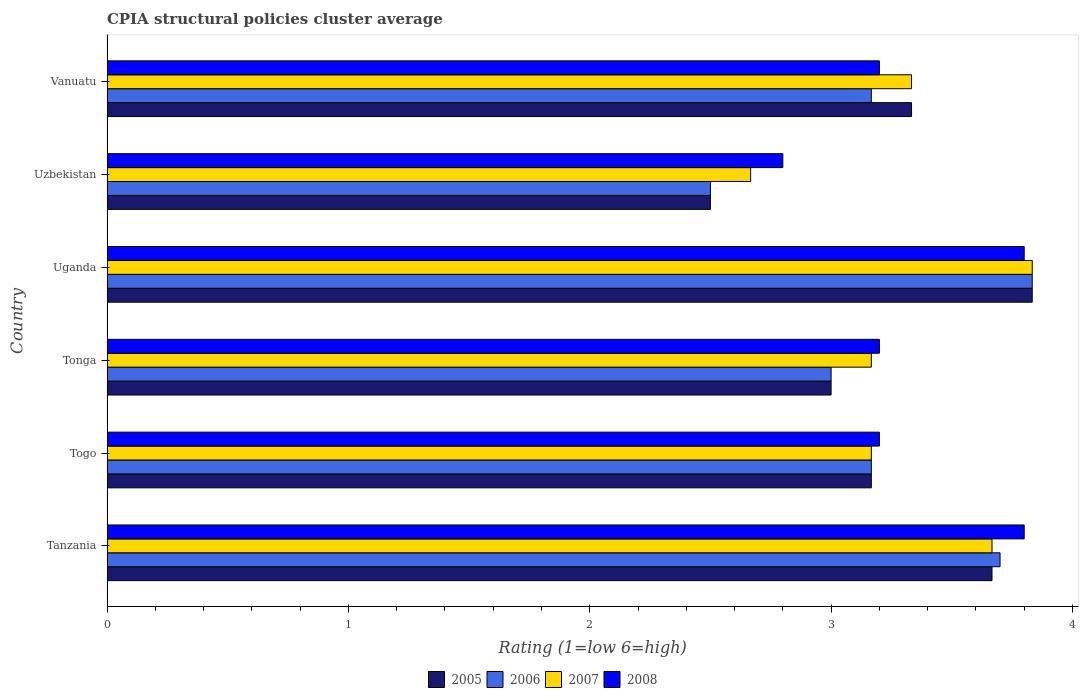How many groups of bars are there?
Give a very brief answer. 6. How many bars are there on the 1st tick from the bottom?
Ensure brevity in your answer.  4. What is the label of the 1st group of bars from the top?
Your answer should be compact. Vanuatu. Across all countries, what is the maximum CPIA rating in 2005?
Offer a very short reply. 3.83. In which country was the CPIA rating in 2005 maximum?
Provide a succinct answer. Uganda. In which country was the CPIA rating in 2007 minimum?
Provide a succinct answer. Uzbekistan. What is the total CPIA rating in 2006 in the graph?
Offer a terse response. 19.37. What is the difference between the CPIA rating in 2007 in Tonga and that in Uzbekistan?
Your answer should be compact. 0.5. What is the difference between the CPIA rating in 2006 in Uzbekistan and the CPIA rating in 2008 in Tonga?
Ensure brevity in your answer.  -0.7. What is the average CPIA rating in 2005 per country?
Provide a succinct answer. 3.25. What is the difference between the CPIA rating in 2006 and CPIA rating in 2005 in Vanuatu?
Provide a succinct answer. -0.17. What is the ratio of the CPIA rating in 2006 in Tanzania to that in Vanuatu?
Provide a short and direct response. 1.17. What is the difference between the highest and the second highest CPIA rating in 2006?
Provide a succinct answer. 0.13. What is the difference between the highest and the lowest CPIA rating in 2008?
Your response must be concise. 1. In how many countries, is the CPIA rating in 2006 greater than the average CPIA rating in 2006 taken over all countries?
Offer a terse response. 2. Is it the case that in every country, the sum of the CPIA rating in 2005 and CPIA rating in 2007 is greater than the sum of CPIA rating in 2008 and CPIA rating in 2006?
Your answer should be compact. No. What does the 3rd bar from the top in Uganda represents?
Your answer should be very brief. 2006. Is it the case that in every country, the sum of the CPIA rating in 2008 and CPIA rating in 2007 is greater than the CPIA rating in 2005?
Keep it short and to the point. Yes. How many countries are there in the graph?
Provide a succinct answer. 6. What is the difference between two consecutive major ticks on the X-axis?
Offer a terse response. 1. Are the values on the major ticks of X-axis written in scientific E-notation?
Your answer should be very brief. No. Does the graph contain grids?
Your answer should be compact. No. Where does the legend appear in the graph?
Keep it short and to the point. Bottom center. What is the title of the graph?
Ensure brevity in your answer.  CPIA structural policies cluster average. What is the label or title of the X-axis?
Ensure brevity in your answer.  Rating (1=low 6=high). What is the label or title of the Y-axis?
Your response must be concise. Country. What is the Rating (1=low 6=high) of 2005 in Tanzania?
Give a very brief answer. 3.67. What is the Rating (1=low 6=high) of 2007 in Tanzania?
Your response must be concise. 3.67. What is the Rating (1=low 6=high) in 2005 in Togo?
Keep it short and to the point. 3.17. What is the Rating (1=low 6=high) in 2006 in Togo?
Make the answer very short. 3.17. What is the Rating (1=low 6=high) of 2007 in Togo?
Keep it short and to the point. 3.17. What is the Rating (1=low 6=high) in 2008 in Togo?
Offer a terse response. 3.2. What is the Rating (1=low 6=high) in 2006 in Tonga?
Provide a succinct answer. 3. What is the Rating (1=low 6=high) in 2007 in Tonga?
Provide a succinct answer. 3.17. What is the Rating (1=low 6=high) of 2005 in Uganda?
Offer a very short reply. 3.83. What is the Rating (1=low 6=high) in 2006 in Uganda?
Provide a succinct answer. 3.83. What is the Rating (1=low 6=high) of 2007 in Uganda?
Provide a short and direct response. 3.83. What is the Rating (1=low 6=high) of 2008 in Uganda?
Give a very brief answer. 3.8. What is the Rating (1=low 6=high) in 2007 in Uzbekistan?
Make the answer very short. 2.67. What is the Rating (1=low 6=high) of 2005 in Vanuatu?
Provide a succinct answer. 3.33. What is the Rating (1=low 6=high) in 2006 in Vanuatu?
Your response must be concise. 3.17. What is the Rating (1=low 6=high) in 2007 in Vanuatu?
Ensure brevity in your answer.  3.33. What is the Rating (1=low 6=high) in 2008 in Vanuatu?
Provide a short and direct response. 3.2. Across all countries, what is the maximum Rating (1=low 6=high) in 2005?
Make the answer very short. 3.83. Across all countries, what is the maximum Rating (1=low 6=high) of 2006?
Make the answer very short. 3.83. Across all countries, what is the maximum Rating (1=low 6=high) in 2007?
Ensure brevity in your answer.  3.83. Across all countries, what is the minimum Rating (1=low 6=high) in 2007?
Offer a very short reply. 2.67. What is the total Rating (1=low 6=high) of 2006 in the graph?
Offer a terse response. 19.37. What is the total Rating (1=low 6=high) in 2007 in the graph?
Ensure brevity in your answer.  19.83. What is the total Rating (1=low 6=high) of 2008 in the graph?
Your answer should be very brief. 20. What is the difference between the Rating (1=low 6=high) of 2006 in Tanzania and that in Togo?
Offer a very short reply. 0.53. What is the difference between the Rating (1=low 6=high) in 2007 in Tanzania and that in Tonga?
Your answer should be compact. 0.5. What is the difference between the Rating (1=low 6=high) in 2008 in Tanzania and that in Tonga?
Provide a succinct answer. 0.6. What is the difference between the Rating (1=low 6=high) in 2006 in Tanzania and that in Uganda?
Give a very brief answer. -0.13. What is the difference between the Rating (1=low 6=high) of 2008 in Tanzania and that in Uganda?
Your response must be concise. 0. What is the difference between the Rating (1=low 6=high) of 2005 in Tanzania and that in Uzbekistan?
Offer a terse response. 1.17. What is the difference between the Rating (1=low 6=high) in 2006 in Tanzania and that in Uzbekistan?
Keep it short and to the point. 1.2. What is the difference between the Rating (1=low 6=high) of 2007 in Tanzania and that in Uzbekistan?
Give a very brief answer. 1. What is the difference between the Rating (1=low 6=high) of 2008 in Tanzania and that in Uzbekistan?
Provide a succinct answer. 1. What is the difference between the Rating (1=low 6=high) in 2006 in Tanzania and that in Vanuatu?
Offer a very short reply. 0.53. What is the difference between the Rating (1=low 6=high) of 2005 in Togo and that in Tonga?
Ensure brevity in your answer.  0.17. What is the difference between the Rating (1=low 6=high) of 2006 in Togo and that in Tonga?
Make the answer very short. 0.17. What is the difference between the Rating (1=low 6=high) in 2008 in Togo and that in Tonga?
Your answer should be compact. 0. What is the difference between the Rating (1=low 6=high) of 2006 in Togo and that in Uganda?
Provide a succinct answer. -0.67. What is the difference between the Rating (1=low 6=high) in 2007 in Togo and that in Uganda?
Your answer should be very brief. -0.67. What is the difference between the Rating (1=low 6=high) in 2005 in Togo and that in Uzbekistan?
Your response must be concise. 0.67. What is the difference between the Rating (1=low 6=high) of 2006 in Togo and that in Uzbekistan?
Provide a succinct answer. 0.67. What is the difference between the Rating (1=low 6=high) of 2007 in Togo and that in Vanuatu?
Ensure brevity in your answer.  -0.17. What is the difference between the Rating (1=low 6=high) of 2006 in Tonga and that in Uganda?
Offer a very short reply. -0.83. What is the difference between the Rating (1=low 6=high) in 2007 in Tonga and that in Uganda?
Provide a short and direct response. -0.67. What is the difference between the Rating (1=low 6=high) of 2005 in Tonga and that in Uzbekistan?
Give a very brief answer. 0.5. What is the difference between the Rating (1=low 6=high) in 2007 in Tonga and that in Uzbekistan?
Your response must be concise. 0.5. What is the difference between the Rating (1=low 6=high) in 2006 in Tonga and that in Vanuatu?
Provide a short and direct response. -0.17. What is the difference between the Rating (1=low 6=high) in 2007 in Tonga and that in Vanuatu?
Keep it short and to the point. -0.17. What is the difference between the Rating (1=low 6=high) in 2008 in Tonga and that in Vanuatu?
Make the answer very short. 0. What is the difference between the Rating (1=low 6=high) of 2005 in Uganda and that in Uzbekistan?
Ensure brevity in your answer.  1.33. What is the difference between the Rating (1=low 6=high) of 2007 in Uganda and that in Uzbekistan?
Offer a very short reply. 1.17. What is the difference between the Rating (1=low 6=high) of 2008 in Uganda and that in Uzbekistan?
Give a very brief answer. 1. What is the difference between the Rating (1=low 6=high) in 2005 in Uganda and that in Vanuatu?
Ensure brevity in your answer.  0.5. What is the difference between the Rating (1=low 6=high) in 2006 in Uganda and that in Vanuatu?
Your answer should be compact. 0.67. What is the difference between the Rating (1=low 6=high) of 2007 in Uganda and that in Vanuatu?
Your response must be concise. 0.5. What is the difference between the Rating (1=low 6=high) in 2008 in Uganda and that in Vanuatu?
Your response must be concise. 0.6. What is the difference between the Rating (1=low 6=high) of 2005 in Uzbekistan and that in Vanuatu?
Ensure brevity in your answer.  -0.83. What is the difference between the Rating (1=low 6=high) of 2007 in Uzbekistan and that in Vanuatu?
Give a very brief answer. -0.67. What is the difference between the Rating (1=low 6=high) in 2005 in Tanzania and the Rating (1=low 6=high) in 2008 in Togo?
Your answer should be compact. 0.47. What is the difference between the Rating (1=low 6=high) of 2006 in Tanzania and the Rating (1=low 6=high) of 2007 in Togo?
Offer a very short reply. 0.53. What is the difference between the Rating (1=low 6=high) in 2007 in Tanzania and the Rating (1=low 6=high) in 2008 in Togo?
Offer a terse response. 0.47. What is the difference between the Rating (1=low 6=high) in 2005 in Tanzania and the Rating (1=low 6=high) in 2006 in Tonga?
Make the answer very short. 0.67. What is the difference between the Rating (1=low 6=high) in 2005 in Tanzania and the Rating (1=low 6=high) in 2008 in Tonga?
Offer a terse response. 0.47. What is the difference between the Rating (1=low 6=high) in 2006 in Tanzania and the Rating (1=low 6=high) in 2007 in Tonga?
Provide a succinct answer. 0.53. What is the difference between the Rating (1=low 6=high) in 2007 in Tanzania and the Rating (1=low 6=high) in 2008 in Tonga?
Your answer should be very brief. 0.47. What is the difference between the Rating (1=low 6=high) in 2005 in Tanzania and the Rating (1=low 6=high) in 2006 in Uganda?
Give a very brief answer. -0.17. What is the difference between the Rating (1=low 6=high) of 2005 in Tanzania and the Rating (1=low 6=high) of 2007 in Uganda?
Provide a succinct answer. -0.17. What is the difference between the Rating (1=low 6=high) in 2005 in Tanzania and the Rating (1=low 6=high) in 2008 in Uganda?
Ensure brevity in your answer.  -0.13. What is the difference between the Rating (1=low 6=high) in 2006 in Tanzania and the Rating (1=low 6=high) in 2007 in Uganda?
Provide a succinct answer. -0.13. What is the difference between the Rating (1=low 6=high) of 2006 in Tanzania and the Rating (1=low 6=high) of 2008 in Uganda?
Offer a terse response. -0.1. What is the difference between the Rating (1=low 6=high) of 2007 in Tanzania and the Rating (1=low 6=high) of 2008 in Uganda?
Offer a very short reply. -0.13. What is the difference between the Rating (1=low 6=high) in 2005 in Tanzania and the Rating (1=low 6=high) in 2006 in Uzbekistan?
Keep it short and to the point. 1.17. What is the difference between the Rating (1=low 6=high) of 2005 in Tanzania and the Rating (1=low 6=high) of 2007 in Uzbekistan?
Offer a very short reply. 1. What is the difference between the Rating (1=low 6=high) of 2005 in Tanzania and the Rating (1=low 6=high) of 2008 in Uzbekistan?
Keep it short and to the point. 0.87. What is the difference between the Rating (1=low 6=high) in 2006 in Tanzania and the Rating (1=low 6=high) in 2008 in Uzbekistan?
Offer a terse response. 0.9. What is the difference between the Rating (1=low 6=high) in 2007 in Tanzania and the Rating (1=low 6=high) in 2008 in Uzbekistan?
Ensure brevity in your answer.  0.87. What is the difference between the Rating (1=low 6=high) of 2005 in Tanzania and the Rating (1=low 6=high) of 2006 in Vanuatu?
Provide a short and direct response. 0.5. What is the difference between the Rating (1=low 6=high) of 2005 in Tanzania and the Rating (1=low 6=high) of 2008 in Vanuatu?
Keep it short and to the point. 0.47. What is the difference between the Rating (1=low 6=high) in 2006 in Tanzania and the Rating (1=low 6=high) in 2007 in Vanuatu?
Keep it short and to the point. 0.37. What is the difference between the Rating (1=low 6=high) of 2006 in Tanzania and the Rating (1=low 6=high) of 2008 in Vanuatu?
Give a very brief answer. 0.5. What is the difference between the Rating (1=low 6=high) in 2007 in Tanzania and the Rating (1=low 6=high) in 2008 in Vanuatu?
Keep it short and to the point. 0.47. What is the difference between the Rating (1=low 6=high) in 2005 in Togo and the Rating (1=low 6=high) in 2006 in Tonga?
Provide a short and direct response. 0.17. What is the difference between the Rating (1=low 6=high) in 2005 in Togo and the Rating (1=low 6=high) in 2007 in Tonga?
Give a very brief answer. 0. What is the difference between the Rating (1=low 6=high) in 2005 in Togo and the Rating (1=low 6=high) in 2008 in Tonga?
Ensure brevity in your answer.  -0.03. What is the difference between the Rating (1=low 6=high) in 2006 in Togo and the Rating (1=low 6=high) in 2007 in Tonga?
Provide a short and direct response. 0. What is the difference between the Rating (1=low 6=high) of 2006 in Togo and the Rating (1=low 6=high) of 2008 in Tonga?
Offer a terse response. -0.03. What is the difference between the Rating (1=low 6=high) in 2007 in Togo and the Rating (1=low 6=high) in 2008 in Tonga?
Your answer should be compact. -0.03. What is the difference between the Rating (1=low 6=high) in 2005 in Togo and the Rating (1=low 6=high) in 2007 in Uganda?
Give a very brief answer. -0.67. What is the difference between the Rating (1=low 6=high) of 2005 in Togo and the Rating (1=low 6=high) of 2008 in Uganda?
Your answer should be compact. -0.63. What is the difference between the Rating (1=low 6=high) in 2006 in Togo and the Rating (1=low 6=high) in 2008 in Uganda?
Make the answer very short. -0.63. What is the difference between the Rating (1=low 6=high) in 2007 in Togo and the Rating (1=low 6=high) in 2008 in Uganda?
Your answer should be compact. -0.63. What is the difference between the Rating (1=low 6=high) of 2005 in Togo and the Rating (1=low 6=high) of 2006 in Uzbekistan?
Give a very brief answer. 0.67. What is the difference between the Rating (1=low 6=high) in 2005 in Togo and the Rating (1=low 6=high) in 2008 in Uzbekistan?
Your answer should be very brief. 0.37. What is the difference between the Rating (1=low 6=high) of 2006 in Togo and the Rating (1=low 6=high) of 2008 in Uzbekistan?
Your response must be concise. 0.37. What is the difference between the Rating (1=low 6=high) of 2007 in Togo and the Rating (1=low 6=high) of 2008 in Uzbekistan?
Offer a terse response. 0.37. What is the difference between the Rating (1=low 6=high) in 2005 in Togo and the Rating (1=low 6=high) in 2006 in Vanuatu?
Keep it short and to the point. 0. What is the difference between the Rating (1=low 6=high) of 2005 in Togo and the Rating (1=low 6=high) of 2007 in Vanuatu?
Provide a short and direct response. -0.17. What is the difference between the Rating (1=low 6=high) of 2005 in Togo and the Rating (1=low 6=high) of 2008 in Vanuatu?
Provide a succinct answer. -0.03. What is the difference between the Rating (1=low 6=high) of 2006 in Togo and the Rating (1=low 6=high) of 2007 in Vanuatu?
Provide a short and direct response. -0.17. What is the difference between the Rating (1=low 6=high) in 2006 in Togo and the Rating (1=low 6=high) in 2008 in Vanuatu?
Provide a short and direct response. -0.03. What is the difference between the Rating (1=low 6=high) of 2007 in Togo and the Rating (1=low 6=high) of 2008 in Vanuatu?
Make the answer very short. -0.03. What is the difference between the Rating (1=low 6=high) of 2005 in Tonga and the Rating (1=low 6=high) of 2006 in Uganda?
Your answer should be compact. -0.83. What is the difference between the Rating (1=low 6=high) in 2005 in Tonga and the Rating (1=low 6=high) in 2007 in Uganda?
Provide a succinct answer. -0.83. What is the difference between the Rating (1=low 6=high) of 2005 in Tonga and the Rating (1=low 6=high) of 2008 in Uganda?
Your answer should be very brief. -0.8. What is the difference between the Rating (1=low 6=high) of 2006 in Tonga and the Rating (1=low 6=high) of 2007 in Uganda?
Make the answer very short. -0.83. What is the difference between the Rating (1=low 6=high) in 2006 in Tonga and the Rating (1=low 6=high) in 2008 in Uganda?
Ensure brevity in your answer.  -0.8. What is the difference between the Rating (1=low 6=high) of 2007 in Tonga and the Rating (1=low 6=high) of 2008 in Uganda?
Keep it short and to the point. -0.63. What is the difference between the Rating (1=low 6=high) in 2006 in Tonga and the Rating (1=low 6=high) in 2008 in Uzbekistan?
Keep it short and to the point. 0.2. What is the difference between the Rating (1=low 6=high) in 2007 in Tonga and the Rating (1=low 6=high) in 2008 in Uzbekistan?
Provide a succinct answer. 0.37. What is the difference between the Rating (1=low 6=high) of 2005 in Tonga and the Rating (1=low 6=high) of 2008 in Vanuatu?
Make the answer very short. -0.2. What is the difference between the Rating (1=low 6=high) in 2006 in Tonga and the Rating (1=low 6=high) in 2007 in Vanuatu?
Give a very brief answer. -0.33. What is the difference between the Rating (1=low 6=high) of 2007 in Tonga and the Rating (1=low 6=high) of 2008 in Vanuatu?
Your answer should be very brief. -0.03. What is the difference between the Rating (1=low 6=high) of 2007 in Uganda and the Rating (1=low 6=high) of 2008 in Uzbekistan?
Give a very brief answer. 1.03. What is the difference between the Rating (1=low 6=high) of 2005 in Uganda and the Rating (1=low 6=high) of 2006 in Vanuatu?
Provide a succinct answer. 0.67. What is the difference between the Rating (1=low 6=high) in 2005 in Uganda and the Rating (1=low 6=high) in 2007 in Vanuatu?
Offer a terse response. 0.5. What is the difference between the Rating (1=low 6=high) of 2005 in Uganda and the Rating (1=low 6=high) of 2008 in Vanuatu?
Your response must be concise. 0.63. What is the difference between the Rating (1=low 6=high) of 2006 in Uganda and the Rating (1=low 6=high) of 2008 in Vanuatu?
Your response must be concise. 0.63. What is the difference between the Rating (1=low 6=high) in 2007 in Uganda and the Rating (1=low 6=high) in 2008 in Vanuatu?
Your response must be concise. 0.63. What is the difference between the Rating (1=low 6=high) in 2005 in Uzbekistan and the Rating (1=low 6=high) in 2006 in Vanuatu?
Your answer should be compact. -0.67. What is the difference between the Rating (1=low 6=high) in 2005 in Uzbekistan and the Rating (1=low 6=high) in 2007 in Vanuatu?
Give a very brief answer. -0.83. What is the difference between the Rating (1=low 6=high) in 2005 in Uzbekistan and the Rating (1=low 6=high) in 2008 in Vanuatu?
Your response must be concise. -0.7. What is the difference between the Rating (1=low 6=high) in 2006 in Uzbekistan and the Rating (1=low 6=high) in 2007 in Vanuatu?
Make the answer very short. -0.83. What is the difference between the Rating (1=low 6=high) of 2007 in Uzbekistan and the Rating (1=low 6=high) of 2008 in Vanuatu?
Offer a very short reply. -0.53. What is the average Rating (1=low 6=high) in 2005 per country?
Keep it short and to the point. 3.25. What is the average Rating (1=low 6=high) of 2006 per country?
Offer a terse response. 3.23. What is the average Rating (1=low 6=high) of 2007 per country?
Your answer should be compact. 3.31. What is the average Rating (1=low 6=high) of 2008 per country?
Ensure brevity in your answer.  3.33. What is the difference between the Rating (1=low 6=high) in 2005 and Rating (1=low 6=high) in 2006 in Tanzania?
Provide a succinct answer. -0.03. What is the difference between the Rating (1=low 6=high) in 2005 and Rating (1=low 6=high) in 2008 in Tanzania?
Provide a short and direct response. -0.13. What is the difference between the Rating (1=low 6=high) in 2007 and Rating (1=low 6=high) in 2008 in Tanzania?
Provide a succinct answer. -0.13. What is the difference between the Rating (1=low 6=high) in 2005 and Rating (1=low 6=high) in 2006 in Togo?
Keep it short and to the point. 0. What is the difference between the Rating (1=low 6=high) of 2005 and Rating (1=low 6=high) of 2008 in Togo?
Your response must be concise. -0.03. What is the difference between the Rating (1=low 6=high) in 2006 and Rating (1=low 6=high) in 2007 in Togo?
Provide a succinct answer. 0. What is the difference between the Rating (1=low 6=high) of 2006 and Rating (1=low 6=high) of 2008 in Togo?
Provide a succinct answer. -0.03. What is the difference between the Rating (1=low 6=high) in 2007 and Rating (1=low 6=high) in 2008 in Togo?
Offer a very short reply. -0.03. What is the difference between the Rating (1=low 6=high) in 2005 and Rating (1=low 6=high) in 2006 in Tonga?
Offer a terse response. 0. What is the difference between the Rating (1=low 6=high) of 2005 and Rating (1=low 6=high) of 2007 in Tonga?
Your response must be concise. -0.17. What is the difference between the Rating (1=low 6=high) of 2007 and Rating (1=low 6=high) of 2008 in Tonga?
Give a very brief answer. -0.03. What is the difference between the Rating (1=low 6=high) in 2005 and Rating (1=low 6=high) in 2006 in Uganda?
Provide a short and direct response. 0. What is the difference between the Rating (1=low 6=high) of 2005 and Rating (1=low 6=high) of 2008 in Uganda?
Your answer should be very brief. 0.03. What is the difference between the Rating (1=low 6=high) in 2006 and Rating (1=low 6=high) in 2007 in Uganda?
Your answer should be compact. 0. What is the difference between the Rating (1=low 6=high) of 2007 and Rating (1=low 6=high) of 2008 in Uganda?
Offer a terse response. 0.03. What is the difference between the Rating (1=low 6=high) in 2005 and Rating (1=low 6=high) in 2006 in Uzbekistan?
Keep it short and to the point. 0. What is the difference between the Rating (1=low 6=high) in 2005 and Rating (1=low 6=high) in 2008 in Uzbekistan?
Make the answer very short. -0.3. What is the difference between the Rating (1=low 6=high) in 2006 and Rating (1=low 6=high) in 2007 in Uzbekistan?
Keep it short and to the point. -0.17. What is the difference between the Rating (1=low 6=high) of 2006 and Rating (1=low 6=high) of 2008 in Uzbekistan?
Make the answer very short. -0.3. What is the difference between the Rating (1=low 6=high) in 2007 and Rating (1=low 6=high) in 2008 in Uzbekistan?
Your answer should be very brief. -0.13. What is the difference between the Rating (1=low 6=high) of 2005 and Rating (1=low 6=high) of 2006 in Vanuatu?
Offer a very short reply. 0.17. What is the difference between the Rating (1=low 6=high) in 2005 and Rating (1=low 6=high) in 2007 in Vanuatu?
Keep it short and to the point. 0. What is the difference between the Rating (1=low 6=high) in 2005 and Rating (1=low 6=high) in 2008 in Vanuatu?
Offer a very short reply. 0.13. What is the difference between the Rating (1=low 6=high) in 2006 and Rating (1=low 6=high) in 2008 in Vanuatu?
Your answer should be very brief. -0.03. What is the difference between the Rating (1=low 6=high) in 2007 and Rating (1=low 6=high) in 2008 in Vanuatu?
Your answer should be compact. 0.13. What is the ratio of the Rating (1=low 6=high) in 2005 in Tanzania to that in Togo?
Ensure brevity in your answer.  1.16. What is the ratio of the Rating (1=low 6=high) of 2006 in Tanzania to that in Togo?
Your response must be concise. 1.17. What is the ratio of the Rating (1=low 6=high) of 2007 in Tanzania to that in Togo?
Keep it short and to the point. 1.16. What is the ratio of the Rating (1=low 6=high) in 2008 in Tanzania to that in Togo?
Provide a succinct answer. 1.19. What is the ratio of the Rating (1=low 6=high) of 2005 in Tanzania to that in Tonga?
Ensure brevity in your answer.  1.22. What is the ratio of the Rating (1=low 6=high) of 2006 in Tanzania to that in Tonga?
Offer a terse response. 1.23. What is the ratio of the Rating (1=low 6=high) of 2007 in Tanzania to that in Tonga?
Your answer should be compact. 1.16. What is the ratio of the Rating (1=low 6=high) of 2008 in Tanzania to that in Tonga?
Your response must be concise. 1.19. What is the ratio of the Rating (1=low 6=high) in 2005 in Tanzania to that in Uganda?
Your answer should be very brief. 0.96. What is the ratio of the Rating (1=low 6=high) in 2006 in Tanzania to that in Uganda?
Keep it short and to the point. 0.97. What is the ratio of the Rating (1=low 6=high) in 2007 in Tanzania to that in Uganda?
Make the answer very short. 0.96. What is the ratio of the Rating (1=low 6=high) of 2008 in Tanzania to that in Uganda?
Ensure brevity in your answer.  1. What is the ratio of the Rating (1=low 6=high) in 2005 in Tanzania to that in Uzbekistan?
Give a very brief answer. 1.47. What is the ratio of the Rating (1=low 6=high) in 2006 in Tanzania to that in Uzbekistan?
Your answer should be compact. 1.48. What is the ratio of the Rating (1=low 6=high) in 2007 in Tanzania to that in Uzbekistan?
Ensure brevity in your answer.  1.38. What is the ratio of the Rating (1=low 6=high) in 2008 in Tanzania to that in Uzbekistan?
Keep it short and to the point. 1.36. What is the ratio of the Rating (1=low 6=high) of 2005 in Tanzania to that in Vanuatu?
Ensure brevity in your answer.  1.1. What is the ratio of the Rating (1=low 6=high) in 2006 in Tanzania to that in Vanuatu?
Keep it short and to the point. 1.17. What is the ratio of the Rating (1=low 6=high) in 2008 in Tanzania to that in Vanuatu?
Give a very brief answer. 1.19. What is the ratio of the Rating (1=low 6=high) in 2005 in Togo to that in Tonga?
Your answer should be compact. 1.06. What is the ratio of the Rating (1=low 6=high) in 2006 in Togo to that in Tonga?
Provide a succinct answer. 1.06. What is the ratio of the Rating (1=low 6=high) in 2007 in Togo to that in Tonga?
Provide a succinct answer. 1. What is the ratio of the Rating (1=low 6=high) in 2005 in Togo to that in Uganda?
Ensure brevity in your answer.  0.83. What is the ratio of the Rating (1=low 6=high) of 2006 in Togo to that in Uganda?
Your answer should be compact. 0.83. What is the ratio of the Rating (1=low 6=high) of 2007 in Togo to that in Uganda?
Your answer should be very brief. 0.83. What is the ratio of the Rating (1=low 6=high) of 2008 in Togo to that in Uganda?
Your response must be concise. 0.84. What is the ratio of the Rating (1=low 6=high) of 2005 in Togo to that in Uzbekistan?
Your answer should be compact. 1.27. What is the ratio of the Rating (1=low 6=high) of 2006 in Togo to that in Uzbekistan?
Make the answer very short. 1.27. What is the ratio of the Rating (1=low 6=high) in 2007 in Togo to that in Uzbekistan?
Provide a succinct answer. 1.19. What is the ratio of the Rating (1=low 6=high) of 2005 in Togo to that in Vanuatu?
Offer a very short reply. 0.95. What is the ratio of the Rating (1=low 6=high) in 2008 in Togo to that in Vanuatu?
Your response must be concise. 1. What is the ratio of the Rating (1=low 6=high) of 2005 in Tonga to that in Uganda?
Provide a short and direct response. 0.78. What is the ratio of the Rating (1=low 6=high) of 2006 in Tonga to that in Uganda?
Your response must be concise. 0.78. What is the ratio of the Rating (1=low 6=high) of 2007 in Tonga to that in Uganda?
Provide a succinct answer. 0.83. What is the ratio of the Rating (1=low 6=high) in 2008 in Tonga to that in Uganda?
Give a very brief answer. 0.84. What is the ratio of the Rating (1=low 6=high) of 2006 in Tonga to that in Uzbekistan?
Your answer should be very brief. 1.2. What is the ratio of the Rating (1=low 6=high) in 2007 in Tonga to that in Uzbekistan?
Your response must be concise. 1.19. What is the ratio of the Rating (1=low 6=high) in 2008 in Tonga to that in Uzbekistan?
Your answer should be very brief. 1.14. What is the ratio of the Rating (1=low 6=high) of 2007 in Tonga to that in Vanuatu?
Provide a succinct answer. 0.95. What is the ratio of the Rating (1=low 6=high) of 2008 in Tonga to that in Vanuatu?
Your answer should be compact. 1. What is the ratio of the Rating (1=low 6=high) in 2005 in Uganda to that in Uzbekistan?
Offer a terse response. 1.53. What is the ratio of the Rating (1=low 6=high) in 2006 in Uganda to that in Uzbekistan?
Make the answer very short. 1.53. What is the ratio of the Rating (1=low 6=high) in 2007 in Uganda to that in Uzbekistan?
Your response must be concise. 1.44. What is the ratio of the Rating (1=low 6=high) in 2008 in Uganda to that in Uzbekistan?
Provide a short and direct response. 1.36. What is the ratio of the Rating (1=low 6=high) in 2005 in Uganda to that in Vanuatu?
Provide a succinct answer. 1.15. What is the ratio of the Rating (1=low 6=high) of 2006 in Uganda to that in Vanuatu?
Provide a short and direct response. 1.21. What is the ratio of the Rating (1=low 6=high) of 2007 in Uganda to that in Vanuatu?
Ensure brevity in your answer.  1.15. What is the ratio of the Rating (1=low 6=high) in 2008 in Uganda to that in Vanuatu?
Provide a succinct answer. 1.19. What is the ratio of the Rating (1=low 6=high) in 2006 in Uzbekistan to that in Vanuatu?
Your answer should be very brief. 0.79. What is the difference between the highest and the second highest Rating (1=low 6=high) of 2005?
Ensure brevity in your answer.  0.17. What is the difference between the highest and the second highest Rating (1=low 6=high) in 2006?
Provide a short and direct response. 0.13. What is the difference between the highest and the second highest Rating (1=low 6=high) in 2007?
Keep it short and to the point. 0.17. What is the difference between the highest and the second highest Rating (1=low 6=high) of 2008?
Your answer should be compact. 0. 